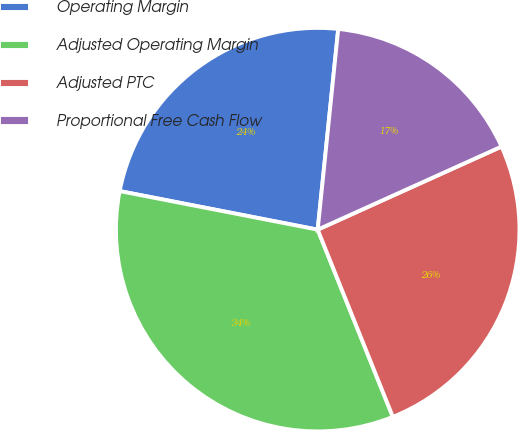<chart> <loc_0><loc_0><loc_500><loc_500><pie_chart><fcel>Operating Margin<fcel>Adjusted Operating Margin<fcel>Adjusted PTC<fcel>Proportional Free Cash Flow<nl><fcel>23.56%<fcel>34.14%<fcel>25.68%<fcel>16.62%<nl></chart> 